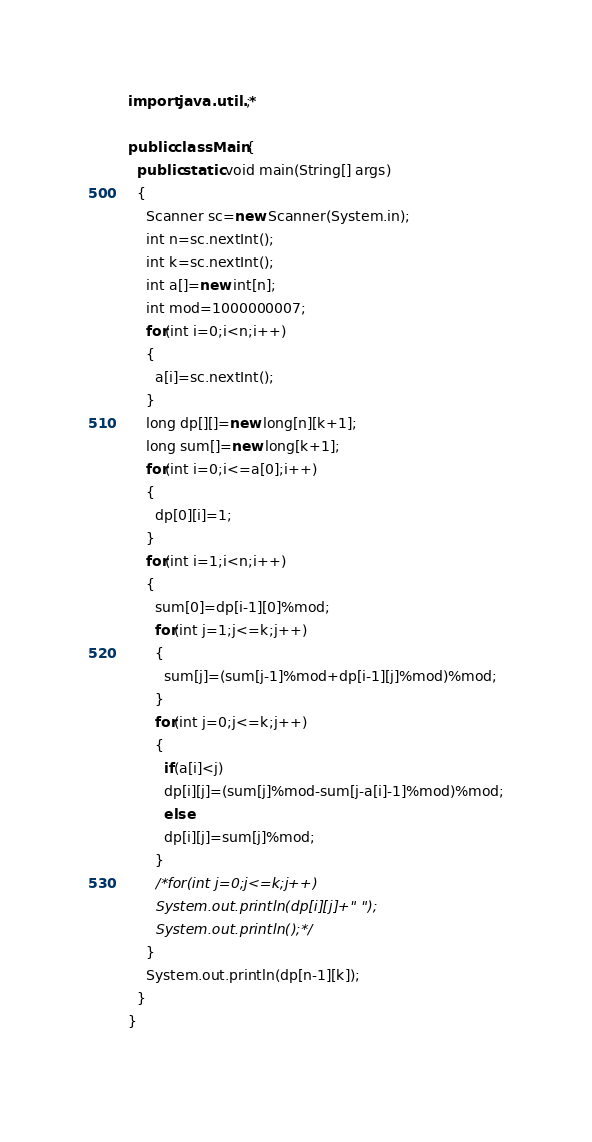<code> <loc_0><loc_0><loc_500><loc_500><_Java_>import java.util.*;

public class Main{
  public static void main(String[] args)
  {
    Scanner sc=new Scanner(System.in);
    int n=sc.nextInt();
    int k=sc.nextInt();
    int a[]=new int[n];
    int mod=1000000007;
    for(int i=0;i<n;i++)
    {
      a[i]=sc.nextInt();
    }
    long dp[][]=new long[n][k+1];
    long sum[]=new long[k+1];
    for(int i=0;i<=a[0];i++)
    {
      dp[0][i]=1;
    }
    for(int i=1;i<n;i++)
    {
      sum[0]=dp[i-1][0]%mod;
      for(int j=1;j<=k;j++)
      {
        sum[j]=(sum[j-1]%mod+dp[i-1][j]%mod)%mod;
      }
      for(int j=0;j<=k;j++)
      {
        if(a[i]<j)
        dp[i][j]=(sum[j]%mod-sum[j-a[i]-1]%mod)%mod;
        else
        dp[i][j]=sum[j]%mod;
      }
      /*for(int j=0;j<=k;j++)
      System.out.println(dp[i][j]+" ");
      System.out.println();*/
    }
    System.out.println(dp[n-1][k]);
  }
}
    </code> 